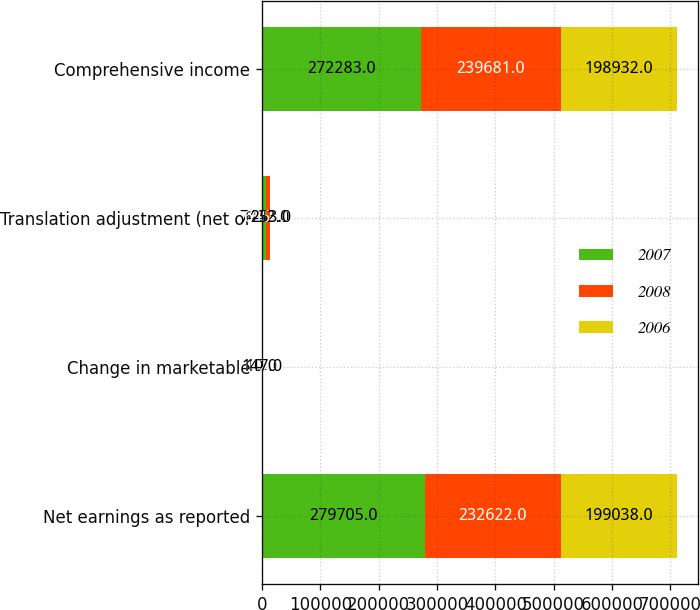Convert chart. <chart><loc_0><loc_0><loc_500><loc_500><stacked_bar_chart><ecel><fcel>Net earnings as reported<fcel>Change in marketable<fcel>Translation adjustment (net of<fcel>Comprehensive income<nl><fcel>2007<fcel>279705<fcel>10<fcel>7432<fcel>272283<nl><fcel>2008<fcel>232622<fcel>102<fcel>6957<fcel>239681<nl><fcel>2006<fcel>199038<fcel>147<fcel>253<fcel>198932<nl></chart> 